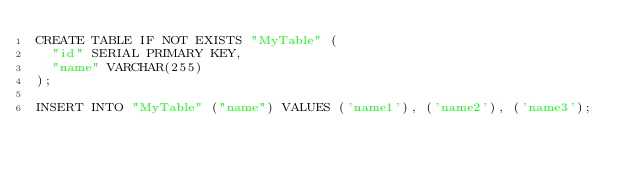Convert code to text. <code><loc_0><loc_0><loc_500><loc_500><_SQL_>CREATE TABLE IF NOT EXISTS "MyTable" (
  "id" SERIAL PRIMARY KEY,
  "name" VARCHAR(255)
);

INSERT INTO "MyTable" ("name") VALUES ('name1'), ('name2'), ('name3');</code> 